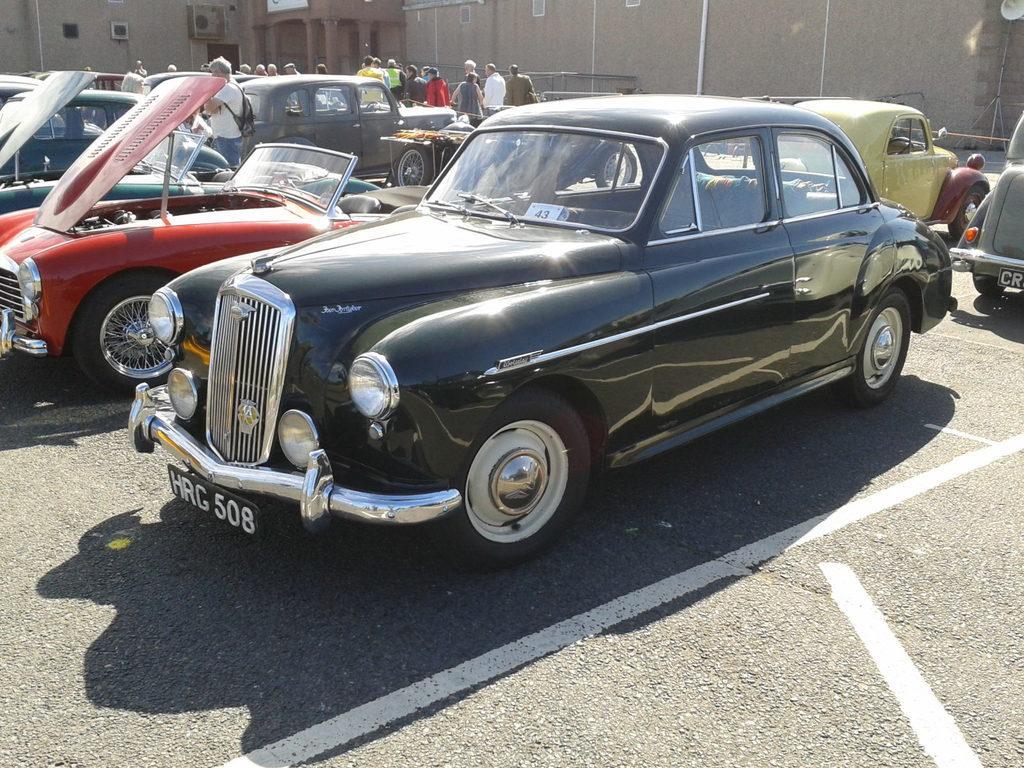How would you summarize this image in a sentence or two? In this picture I can see cars and people are standing on the ground. In the background I can see buildings. Here I can see white color lines on the road. 